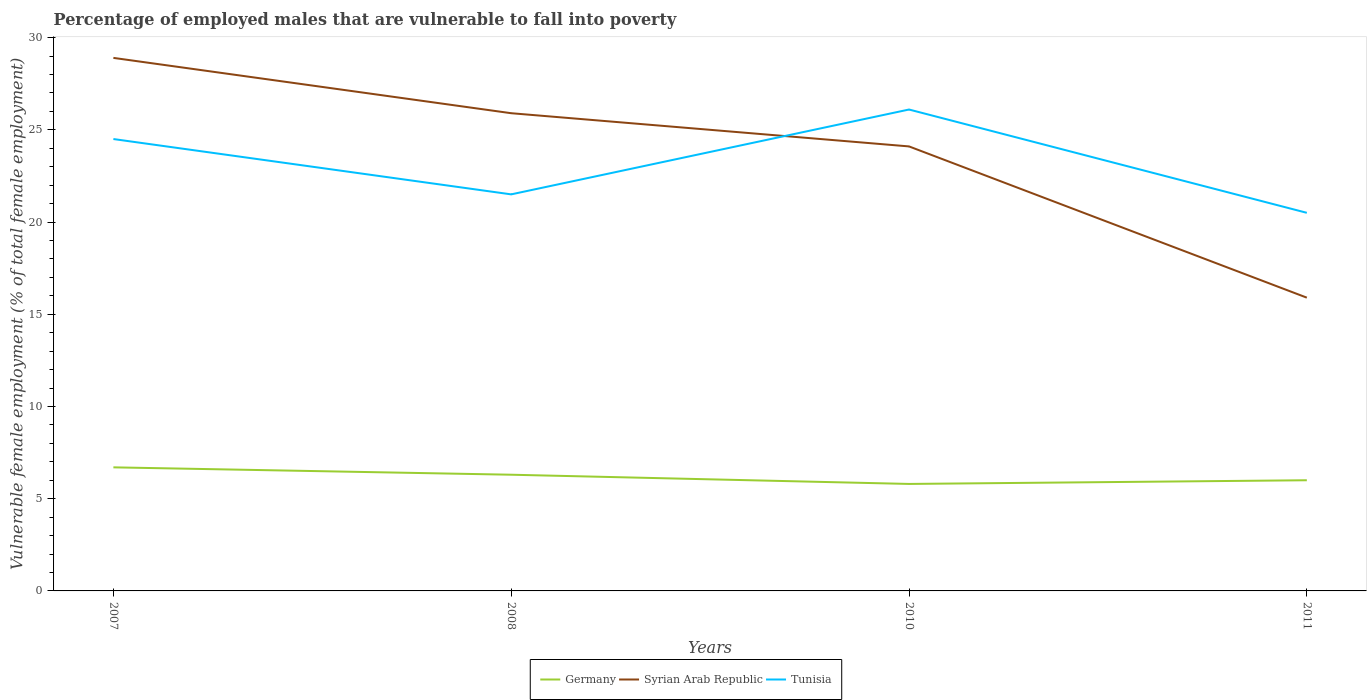How many different coloured lines are there?
Your answer should be compact. 3. Does the line corresponding to Tunisia intersect with the line corresponding to Syrian Arab Republic?
Your answer should be very brief. Yes. Is the number of lines equal to the number of legend labels?
Your answer should be very brief. Yes. Across all years, what is the maximum percentage of employed males who are vulnerable to fall into poverty in Tunisia?
Your answer should be compact. 20.5. What is the total percentage of employed males who are vulnerable to fall into poverty in Syrian Arab Republic in the graph?
Make the answer very short. 8.2. What is the difference between the highest and the second highest percentage of employed males who are vulnerable to fall into poverty in Syrian Arab Republic?
Your answer should be very brief. 13. What is the difference between the highest and the lowest percentage of employed males who are vulnerable to fall into poverty in Syrian Arab Republic?
Your response must be concise. 3. Is the percentage of employed males who are vulnerable to fall into poverty in Germany strictly greater than the percentage of employed males who are vulnerable to fall into poverty in Syrian Arab Republic over the years?
Keep it short and to the point. Yes. How many years are there in the graph?
Provide a succinct answer. 4. Are the values on the major ticks of Y-axis written in scientific E-notation?
Offer a terse response. No. Does the graph contain any zero values?
Ensure brevity in your answer.  No. Does the graph contain grids?
Make the answer very short. No. Where does the legend appear in the graph?
Your answer should be compact. Bottom center. How many legend labels are there?
Make the answer very short. 3. What is the title of the graph?
Your answer should be very brief. Percentage of employed males that are vulnerable to fall into poverty. Does "Denmark" appear as one of the legend labels in the graph?
Give a very brief answer. No. What is the label or title of the Y-axis?
Provide a short and direct response. Vulnerable female employment (% of total female employment). What is the Vulnerable female employment (% of total female employment) of Germany in 2007?
Your answer should be very brief. 6.7. What is the Vulnerable female employment (% of total female employment) in Syrian Arab Republic in 2007?
Your response must be concise. 28.9. What is the Vulnerable female employment (% of total female employment) in Tunisia in 2007?
Ensure brevity in your answer.  24.5. What is the Vulnerable female employment (% of total female employment) in Germany in 2008?
Provide a succinct answer. 6.3. What is the Vulnerable female employment (% of total female employment) in Syrian Arab Republic in 2008?
Provide a succinct answer. 25.9. What is the Vulnerable female employment (% of total female employment) of Germany in 2010?
Keep it short and to the point. 5.8. What is the Vulnerable female employment (% of total female employment) in Syrian Arab Republic in 2010?
Provide a short and direct response. 24.1. What is the Vulnerable female employment (% of total female employment) of Tunisia in 2010?
Your response must be concise. 26.1. What is the Vulnerable female employment (% of total female employment) of Germany in 2011?
Give a very brief answer. 6. What is the Vulnerable female employment (% of total female employment) of Syrian Arab Republic in 2011?
Your response must be concise. 15.9. Across all years, what is the maximum Vulnerable female employment (% of total female employment) in Germany?
Offer a terse response. 6.7. Across all years, what is the maximum Vulnerable female employment (% of total female employment) in Syrian Arab Republic?
Provide a short and direct response. 28.9. Across all years, what is the maximum Vulnerable female employment (% of total female employment) of Tunisia?
Your response must be concise. 26.1. Across all years, what is the minimum Vulnerable female employment (% of total female employment) of Germany?
Your answer should be compact. 5.8. Across all years, what is the minimum Vulnerable female employment (% of total female employment) of Syrian Arab Republic?
Keep it short and to the point. 15.9. What is the total Vulnerable female employment (% of total female employment) in Germany in the graph?
Keep it short and to the point. 24.8. What is the total Vulnerable female employment (% of total female employment) of Syrian Arab Republic in the graph?
Offer a terse response. 94.8. What is the total Vulnerable female employment (% of total female employment) of Tunisia in the graph?
Keep it short and to the point. 92.6. What is the difference between the Vulnerable female employment (% of total female employment) of Germany in 2007 and that in 2010?
Keep it short and to the point. 0.9. What is the difference between the Vulnerable female employment (% of total female employment) in Syrian Arab Republic in 2007 and that in 2010?
Make the answer very short. 4.8. What is the difference between the Vulnerable female employment (% of total female employment) of Germany in 2007 and that in 2011?
Give a very brief answer. 0.7. What is the difference between the Vulnerable female employment (% of total female employment) of Syrian Arab Republic in 2007 and that in 2011?
Provide a short and direct response. 13. What is the difference between the Vulnerable female employment (% of total female employment) in Syrian Arab Republic in 2008 and that in 2010?
Offer a terse response. 1.8. What is the difference between the Vulnerable female employment (% of total female employment) in Tunisia in 2008 and that in 2010?
Provide a succinct answer. -4.6. What is the difference between the Vulnerable female employment (% of total female employment) of Syrian Arab Republic in 2010 and that in 2011?
Your response must be concise. 8.2. What is the difference between the Vulnerable female employment (% of total female employment) of Germany in 2007 and the Vulnerable female employment (% of total female employment) of Syrian Arab Republic in 2008?
Provide a short and direct response. -19.2. What is the difference between the Vulnerable female employment (% of total female employment) in Germany in 2007 and the Vulnerable female employment (% of total female employment) in Tunisia in 2008?
Provide a short and direct response. -14.8. What is the difference between the Vulnerable female employment (% of total female employment) in Syrian Arab Republic in 2007 and the Vulnerable female employment (% of total female employment) in Tunisia in 2008?
Ensure brevity in your answer.  7.4. What is the difference between the Vulnerable female employment (% of total female employment) of Germany in 2007 and the Vulnerable female employment (% of total female employment) of Syrian Arab Republic in 2010?
Ensure brevity in your answer.  -17.4. What is the difference between the Vulnerable female employment (% of total female employment) in Germany in 2007 and the Vulnerable female employment (% of total female employment) in Tunisia in 2010?
Provide a short and direct response. -19.4. What is the difference between the Vulnerable female employment (% of total female employment) in Germany in 2007 and the Vulnerable female employment (% of total female employment) in Syrian Arab Republic in 2011?
Give a very brief answer. -9.2. What is the difference between the Vulnerable female employment (% of total female employment) of Germany in 2007 and the Vulnerable female employment (% of total female employment) of Tunisia in 2011?
Make the answer very short. -13.8. What is the difference between the Vulnerable female employment (% of total female employment) of Syrian Arab Republic in 2007 and the Vulnerable female employment (% of total female employment) of Tunisia in 2011?
Ensure brevity in your answer.  8.4. What is the difference between the Vulnerable female employment (% of total female employment) of Germany in 2008 and the Vulnerable female employment (% of total female employment) of Syrian Arab Republic in 2010?
Provide a succinct answer. -17.8. What is the difference between the Vulnerable female employment (% of total female employment) in Germany in 2008 and the Vulnerable female employment (% of total female employment) in Tunisia in 2010?
Provide a short and direct response. -19.8. What is the difference between the Vulnerable female employment (% of total female employment) of Germany in 2008 and the Vulnerable female employment (% of total female employment) of Syrian Arab Republic in 2011?
Offer a terse response. -9.6. What is the difference between the Vulnerable female employment (% of total female employment) of Germany in 2008 and the Vulnerable female employment (% of total female employment) of Tunisia in 2011?
Your answer should be very brief. -14.2. What is the difference between the Vulnerable female employment (% of total female employment) of Germany in 2010 and the Vulnerable female employment (% of total female employment) of Tunisia in 2011?
Keep it short and to the point. -14.7. What is the average Vulnerable female employment (% of total female employment) of Germany per year?
Offer a very short reply. 6.2. What is the average Vulnerable female employment (% of total female employment) of Syrian Arab Republic per year?
Your answer should be compact. 23.7. What is the average Vulnerable female employment (% of total female employment) in Tunisia per year?
Keep it short and to the point. 23.15. In the year 2007, what is the difference between the Vulnerable female employment (% of total female employment) in Germany and Vulnerable female employment (% of total female employment) in Syrian Arab Republic?
Offer a terse response. -22.2. In the year 2007, what is the difference between the Vulnerable female employment (% of total female employment) in Germany and Vulnerable female employment (% of total female employment) in Tunisia?
Provide a short and direct response. -17.8. In the year 2008, what is the difference between the Vulnerable female employment (% of total female employment) in Germany and Vulnerable female employment (% of total female employment) in Syrian Arab Republic?
Provide a short and direct response. -19.6. In the year 2008, what is the difference between the Vulnerable female employment (% of total female employment) in Germany and Vulnerable female employment (% of total female employment) in Tunisia?
Keep it short and to the point. -15.2. In the year 2010, what is the difference between the Vulnerable female employment (% of total female employment) in Germany and Vulnerable female employment (% of total female employment) in Syrian Arab Republic?
Ensure brevity in your answer.  -18.3. In the year 2010, what is the difference between the Vulnerable female employment (% of total female employment) in Germany and Vulnerable female employment (% of total female employment) in Tunisia?
Offer a terse response. -20.3. In the year 2010, what is the difference between the Vulnerable female employment (% of total female employment) of Syrian Arab Republic and Vulnerable female employment (% of total female employment) of Tunisia?
Make the answer very short. -2. What is the ratio of the Vulnerable female employment (% of total female employment) of Germany in 2007 to that in 2008?
Offer a very short reply. 1.06. What is the ratio of the Vulnerable female employment (% of total female employment) in Syrian Arab Republic in 2007 to that in 2008?
Your answer should be very brief. 1.12. What is the ratio of the Vulnerable female employment (% of total female employment) in Tunisia in 2007 to that in 2008?
Your response must be concise. 1.14. What is the ratio of the Vulnerable female employment (% of total female employment) in Germany in 2007 to that in 2010?
Keep it short and to the point. 1.16. What is the ratio of the Vulnerable female employment (% of total female employment) of Syrian Arab Republic in 2007 to that in 2010?
Your answer should be compact. 1.2. What is the ratio of the Vulnerable female employment (% of total female employment) in Tunisia in 2007 to that in 2010?
Provide a short and direct response. 0.94. What is the ratio of the Vulnerable female employment (% of total female employment) of Germany in 2007 to that in 2011?
Make the answer very short. 1.12. What is the ratio of the Vulnerable female employment (% of total female employment) in Syrian Arab Republic in 2007 to that in 2011?
Offer a very short reply. 1.82. What is the ratio of the Vulnerable female employment (% of total female employment) in Tunisia in 2007 to that in 2011?
Keep it short and to the point. 1.2. What is the ratio of the Vulnerable female employment (% of total female employment) in Germany in 2008 to that in 2010?
Keep it short and to the point. 1.09. What is the ratio of the Vulnerable female employment (% of total female employment) in Syrian Arab Republic in 2008 to that in 2010?
Your answer should be compact. 1.07. What is the ratio of the Vulnerable female employment (% of total female employment) in Tunisia in 2008 to that in 2010?
Your response must be concise. 0.82. What is the ratio of the Vulnerable female employment (% of total female employment) in Germany in 2008 to that in 2011?
Make the answer very short. 1.05. What is the ratio of the Vulnerable female employment (% of total female employment) of Syrian Arab Republic in 2008 to that in 2011?
Offer a terse response. 1.63. What is the ratio of the Vulnerable female employment (% of total female employment) of Tunisia in 2008 to that in 2011?
Provide a succinct answer. 1.05. What is the ratio of the Vulnerable female employment (% of total female employment) in Germany in 2010 to that in 2011?
Your response must be concise. 0.97. What is the ratio of the Vulnerable female employment (% of total female employment) of Syrian Arab Republic in 2010 to that in 2011?
Your answer should be very brief. 1.52. What is the ratio of the Vulnerable female employment (% of total female employment) of Tunisia in 2010 to that in 2011?
Provide a short and direct response. 1.27. What is the difference between the highest and the second highest Vulnerable female employment (% of total female employment) in Tunisia?
Provide a succinct answer. 1.6. What is the difference between the highest and the lowest Vulnerable female employment (% of total female employment) of Tunisia?
Your response must be concise. 5.6. 